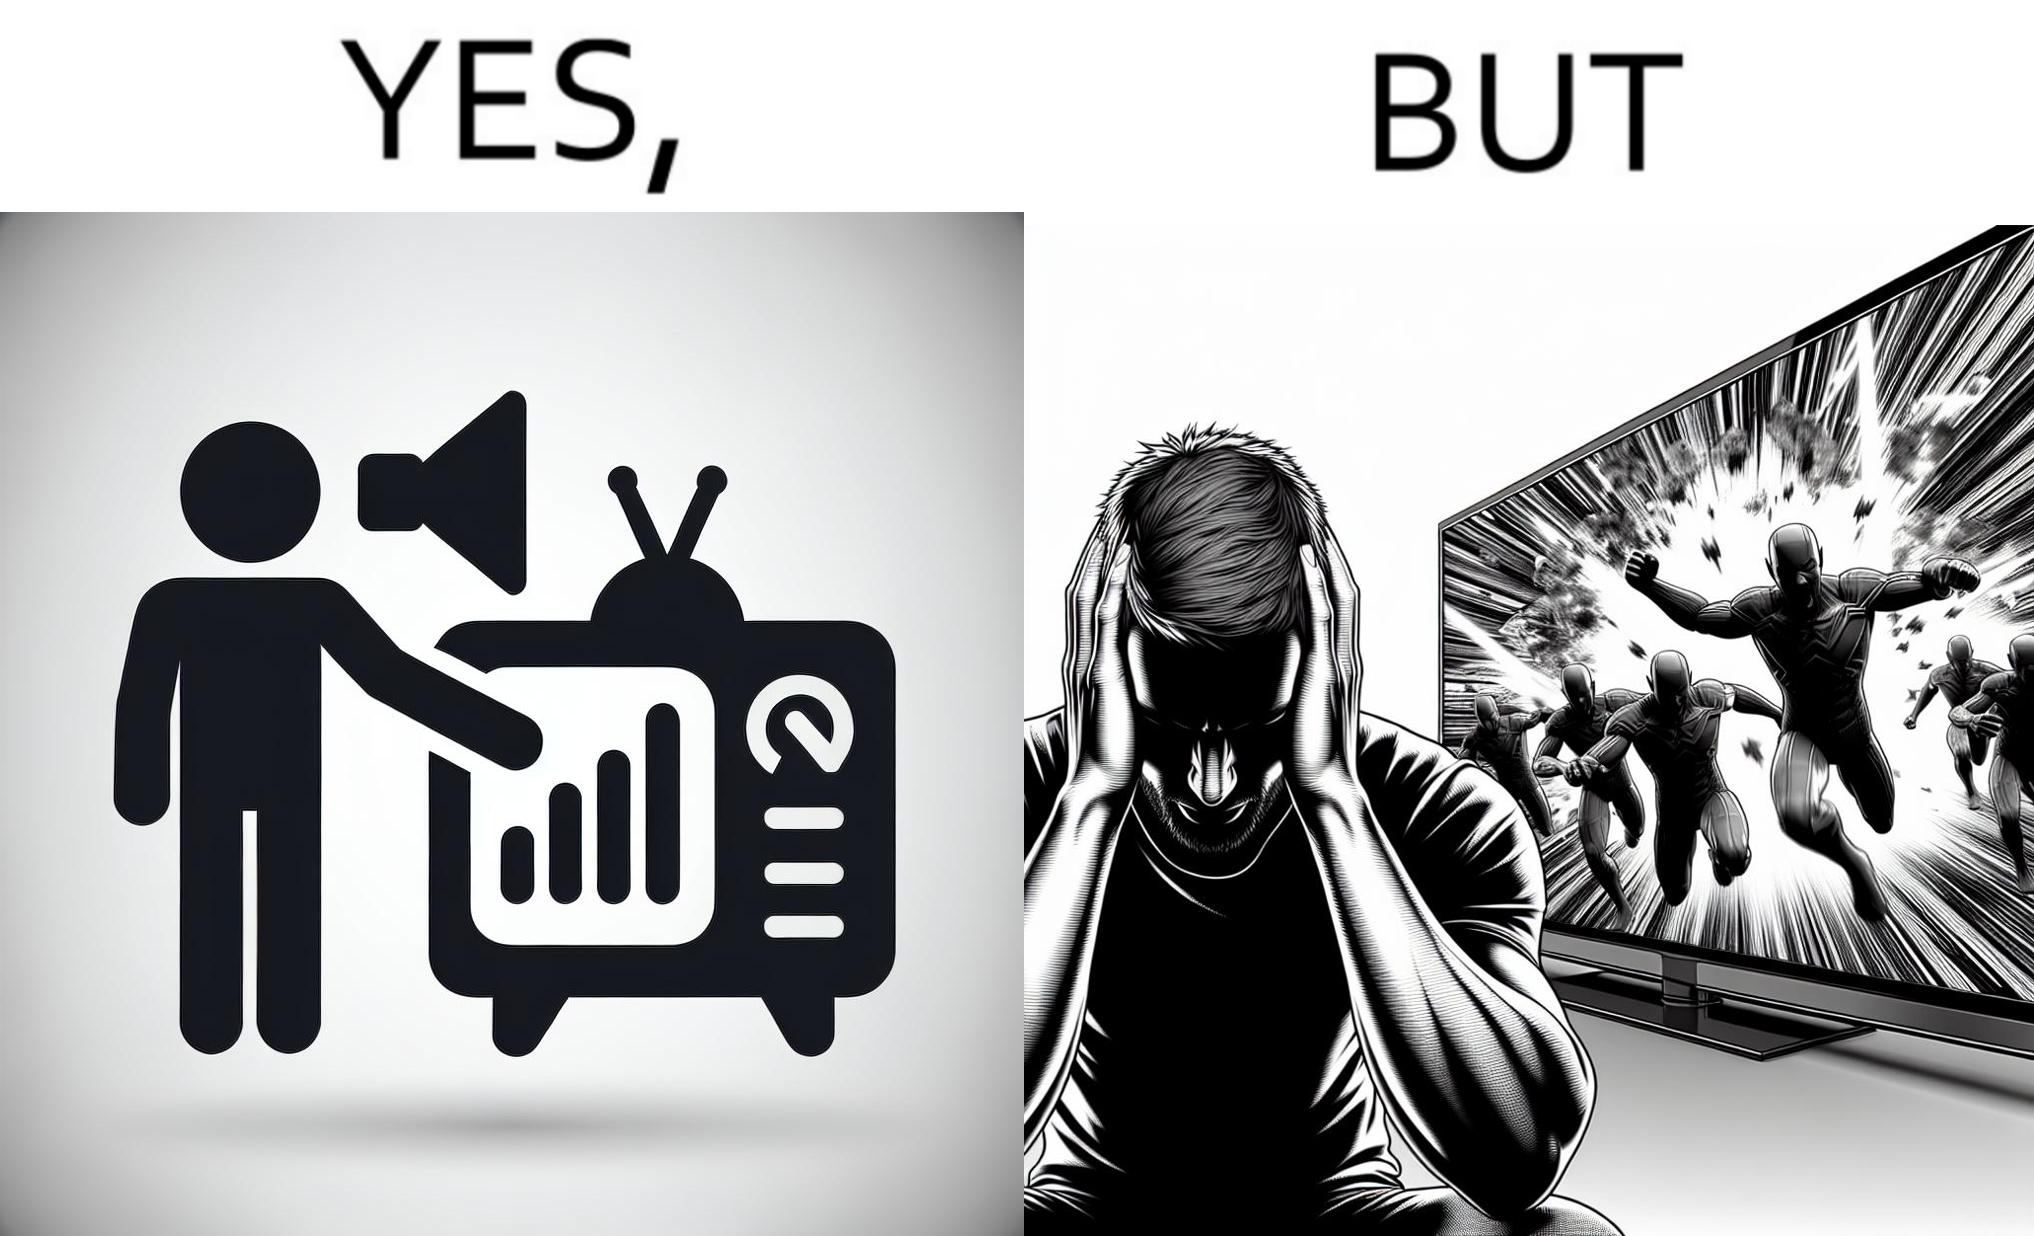Would you classify this image as satirical? Yes, this image is satirical. 